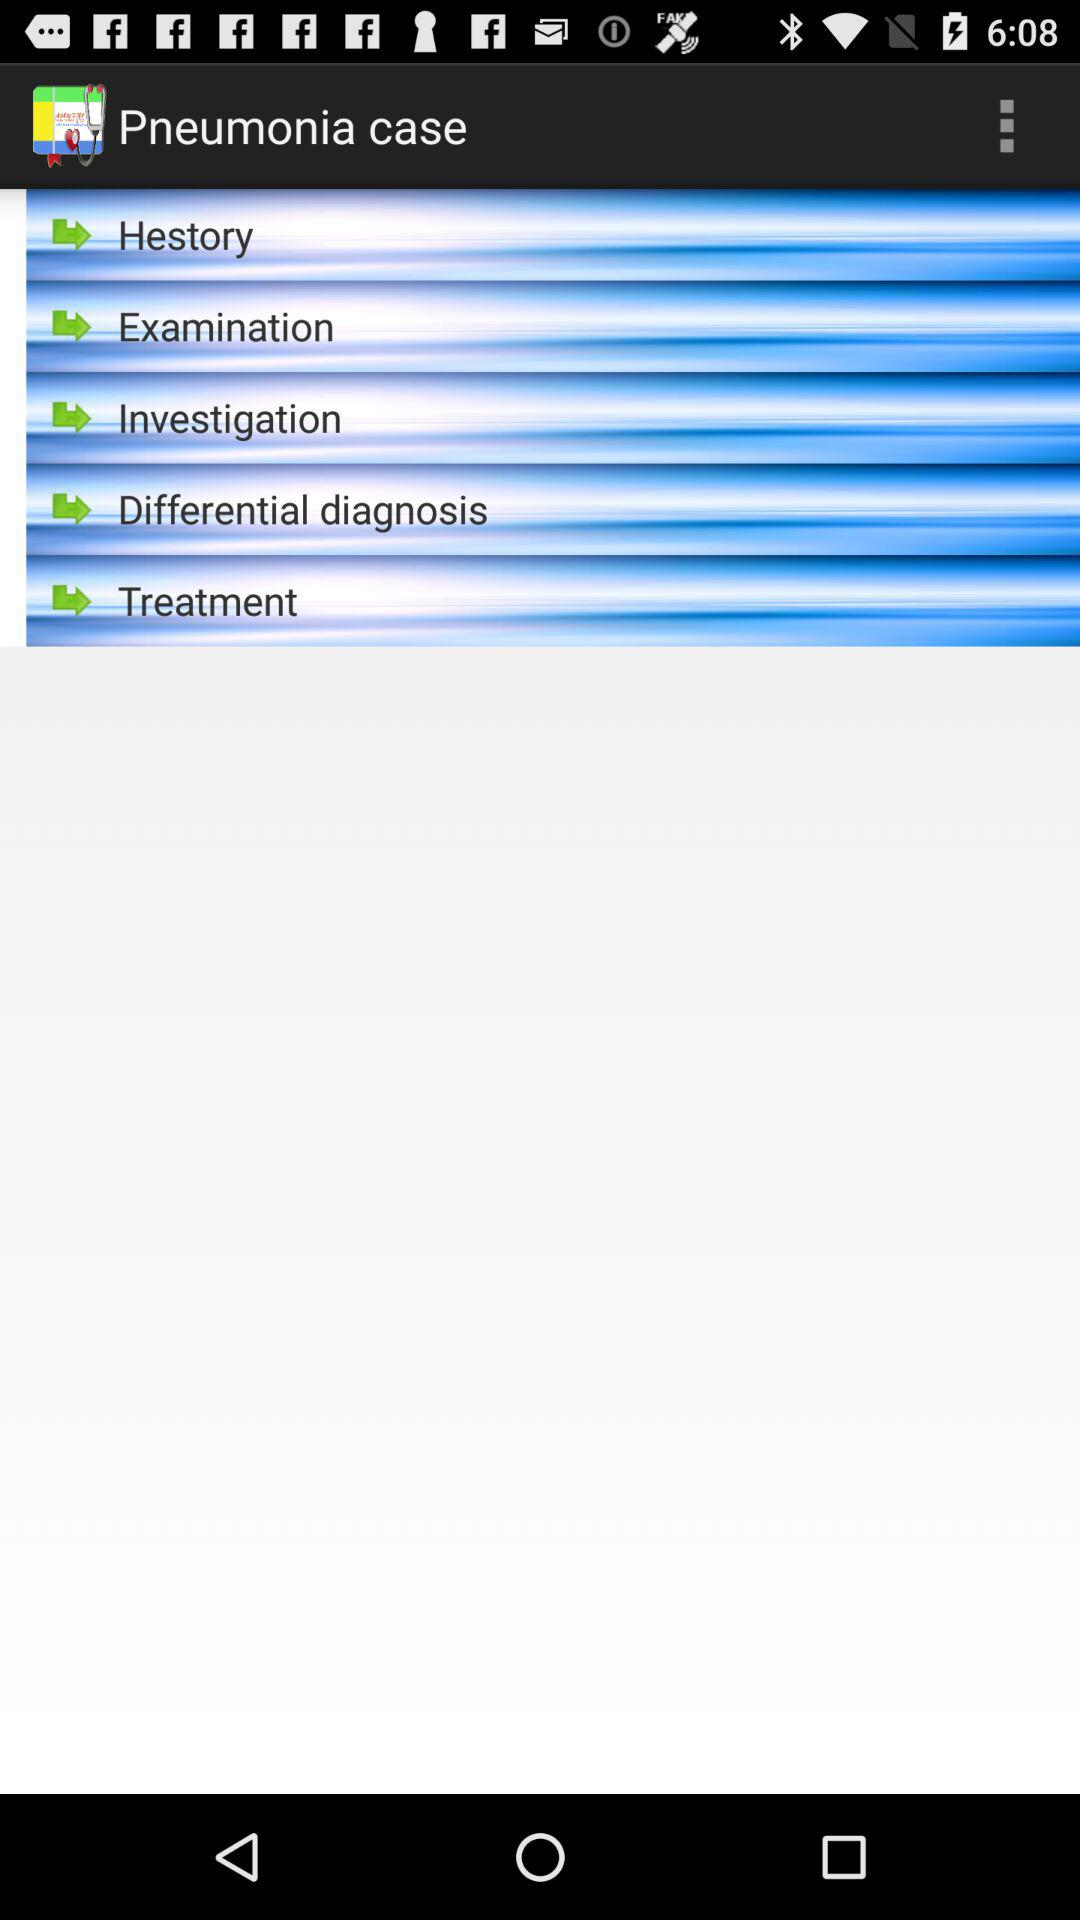What is the application name? The application name is "Pneumonia case". 